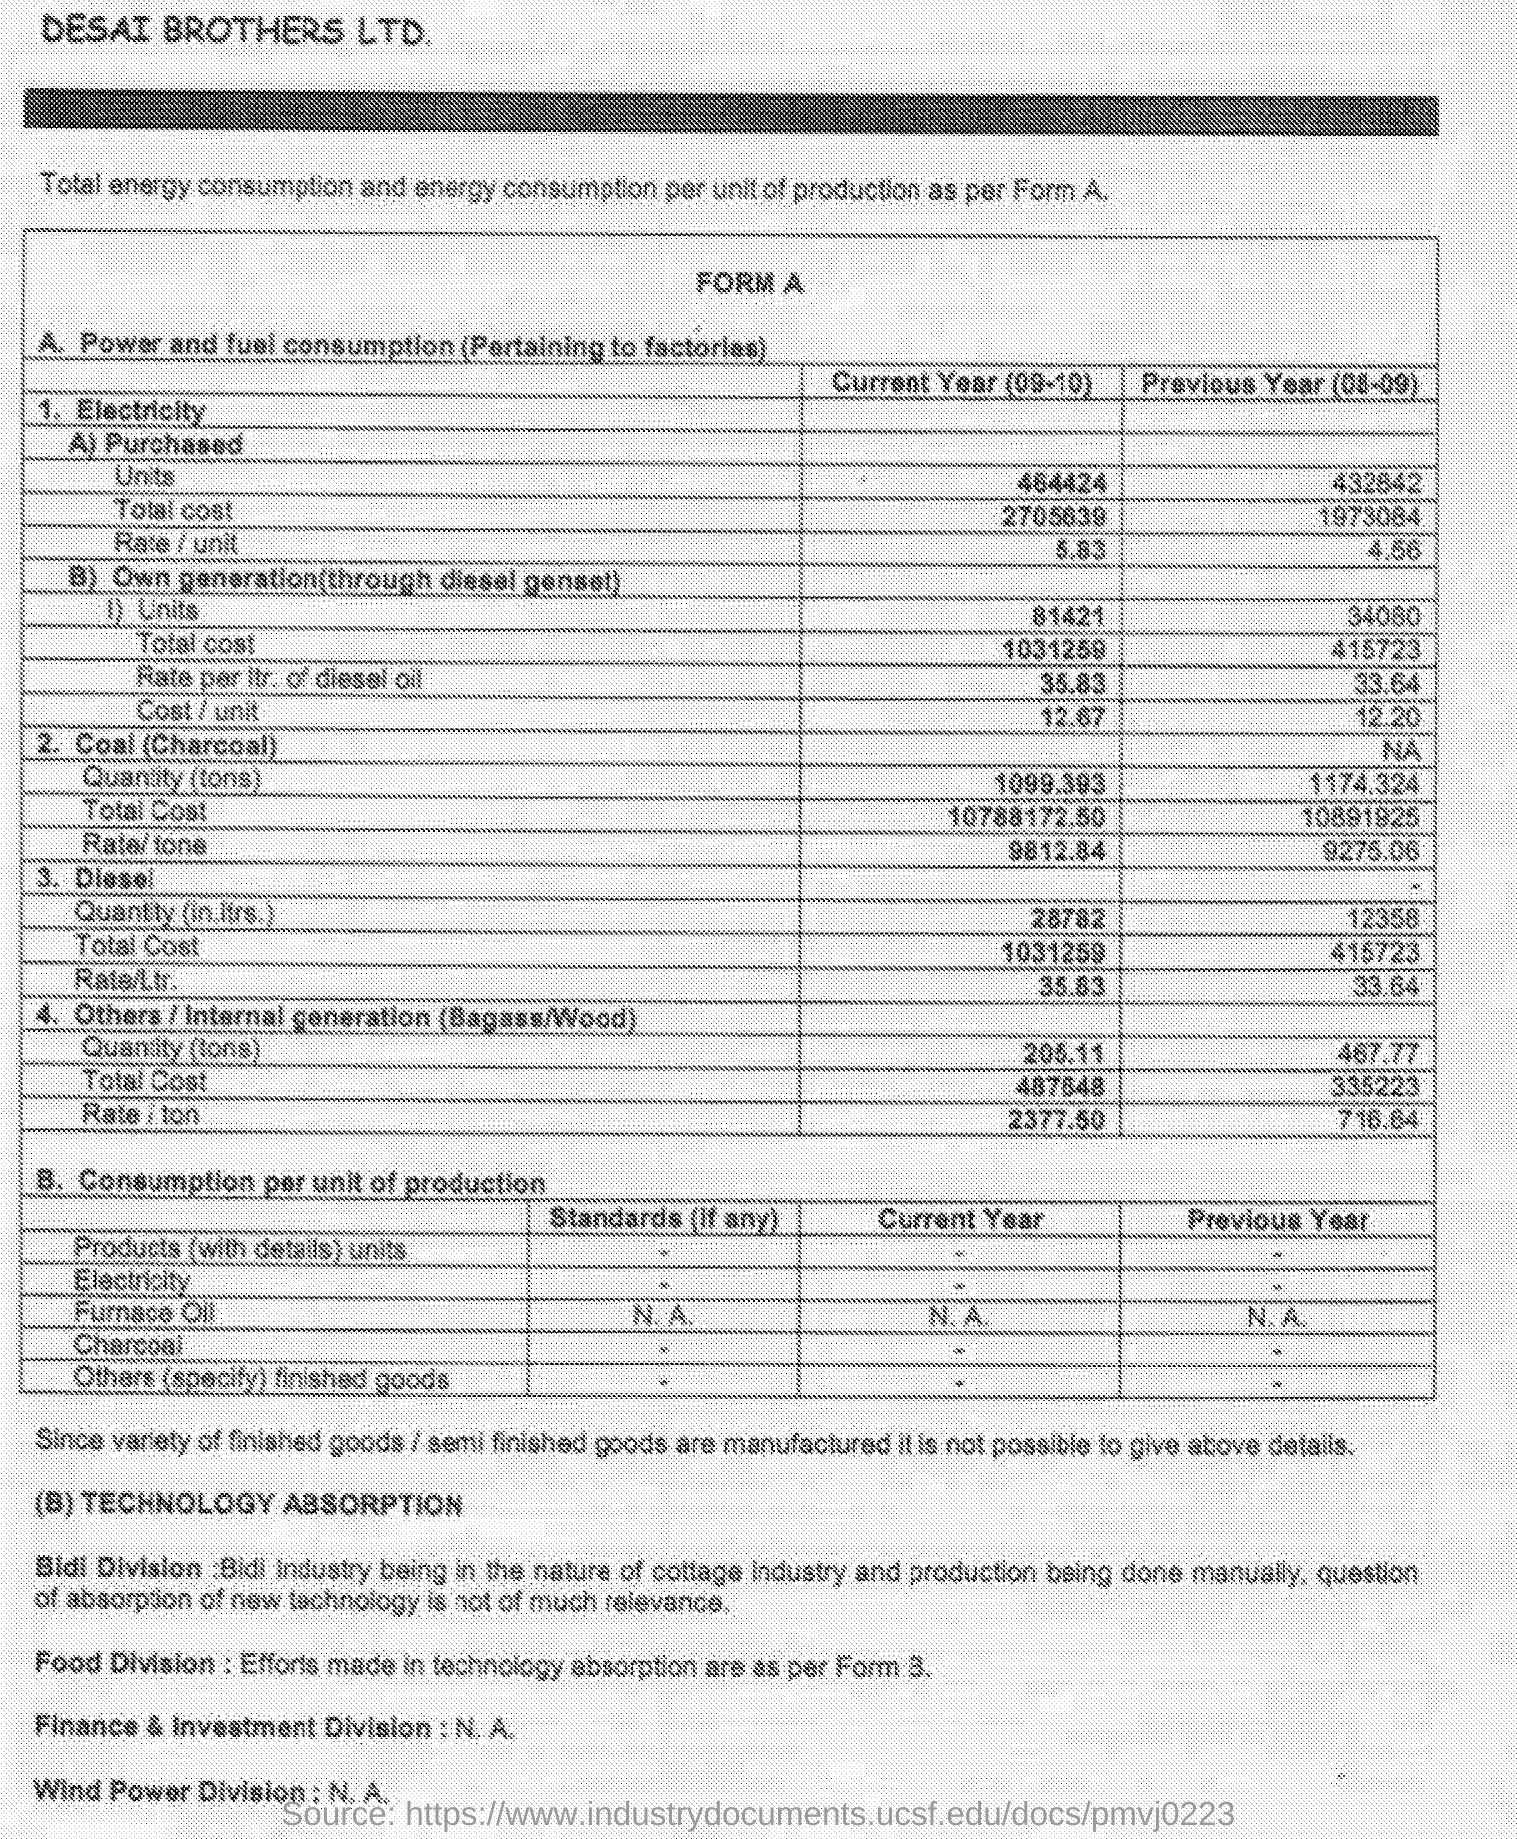What is the quantity (in ltrs)for diesel in the current year (09-10)?
Offer a very short reply. 28782. What is the quantity (in ltrs)for diesel in the previous year (08-09)?
Your answer should be compact. 12358. What is the quantity (tons)for coal(charcoal) in the current year (09-10)?
Give a very brief answer. 1099.393. What is the quantity (tons)for coal(charcoal) in the previous year (08-09)?
Your response must be concise. 1174.324. What is the total cost for diesel in the current year (09-10)?
Offer a terse response. 1031259. What is the rate/ltr for diesel in the previous year (08-09)?
Provide a short and direct response. 33.64. What is the rate/ltr for diesel in the current year (09-10)?
Provide a succinct answer. 35.83. What is the total cost for coal(charcoal) in the current year (09-10)?
Your answer should be compact. 10788172.50. What is the total cost for coal(charcoal) in the previous year (08-09)?
Keep it short and to the point. 10891925. 